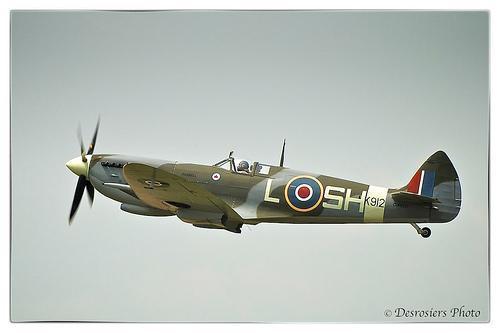How many aircraft are visible?
Give a very brief answer. 1. 